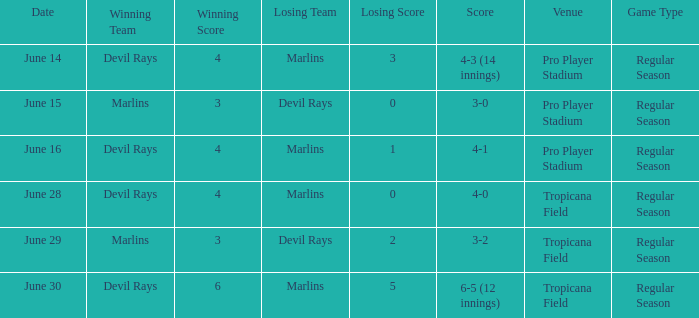What was the score on june 29? 3-2. 